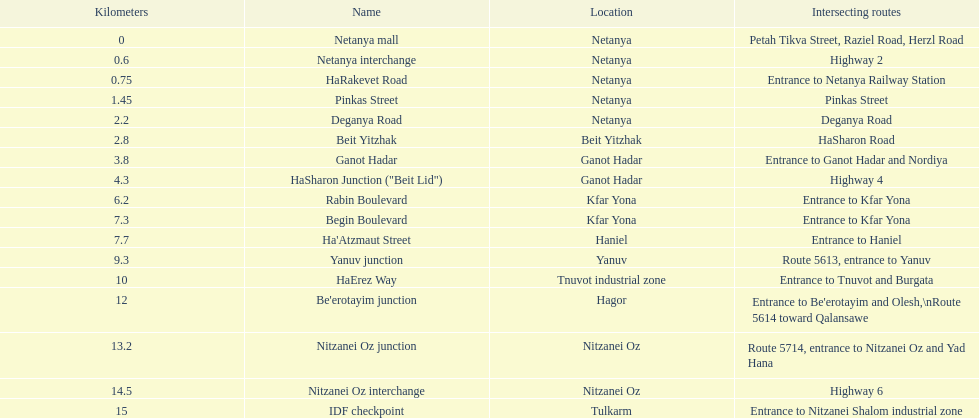Which location comes after kfar yona? Haniel. 